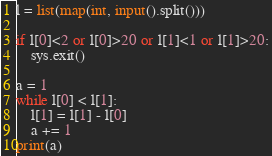Convert code to text. <code><loc_0><loc_0><loc_500><loc_500><_Python_>l = list(map(int, input().split()))

if l[0]<2 or l[0]>20 or l[1]<1 or l[1]>20:
	sys.exit()

a = 1
while l[0] < l[1]:
	l[1] = l[1] - l[0]
	a += 1
print(a)</code> 